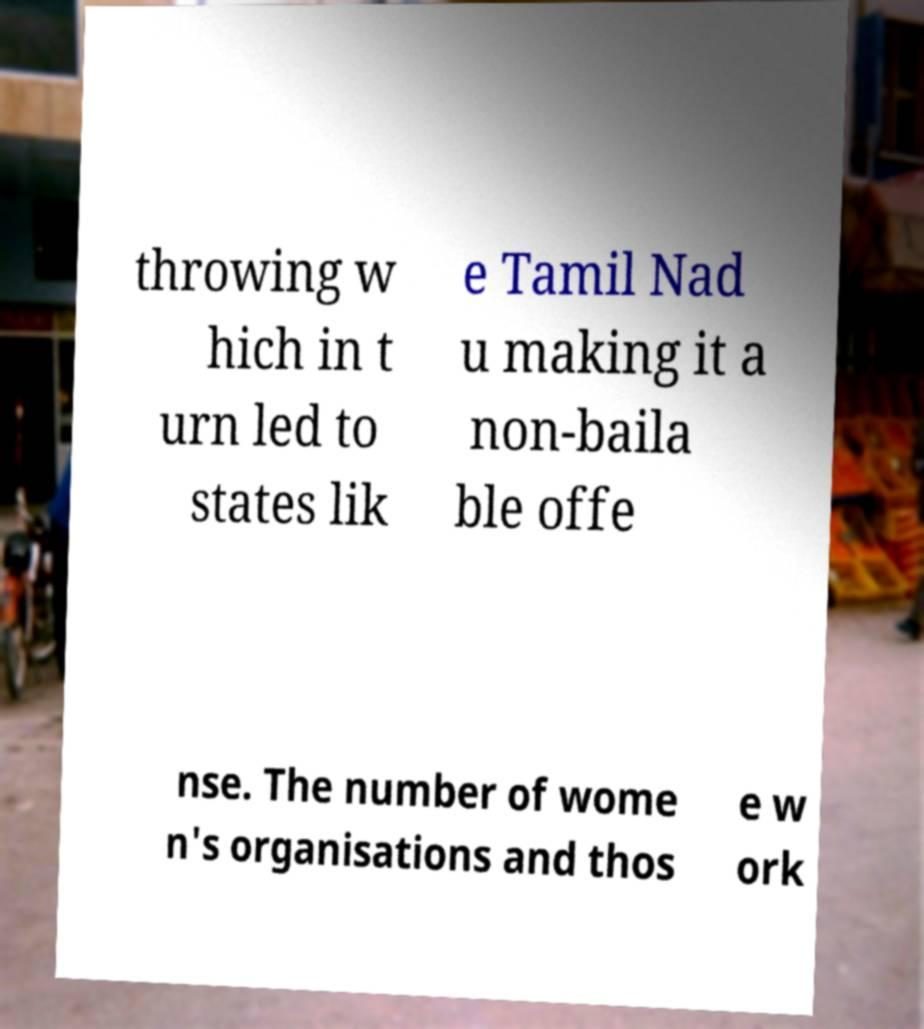There's text embedded in this image that I need extracted. Can you transcribe it verbatim? throwing w hich in t urn led to states lik e Tamil Nad u making it a non-baila ble offe nse. The number of wome n's organisations and thos e w ork 